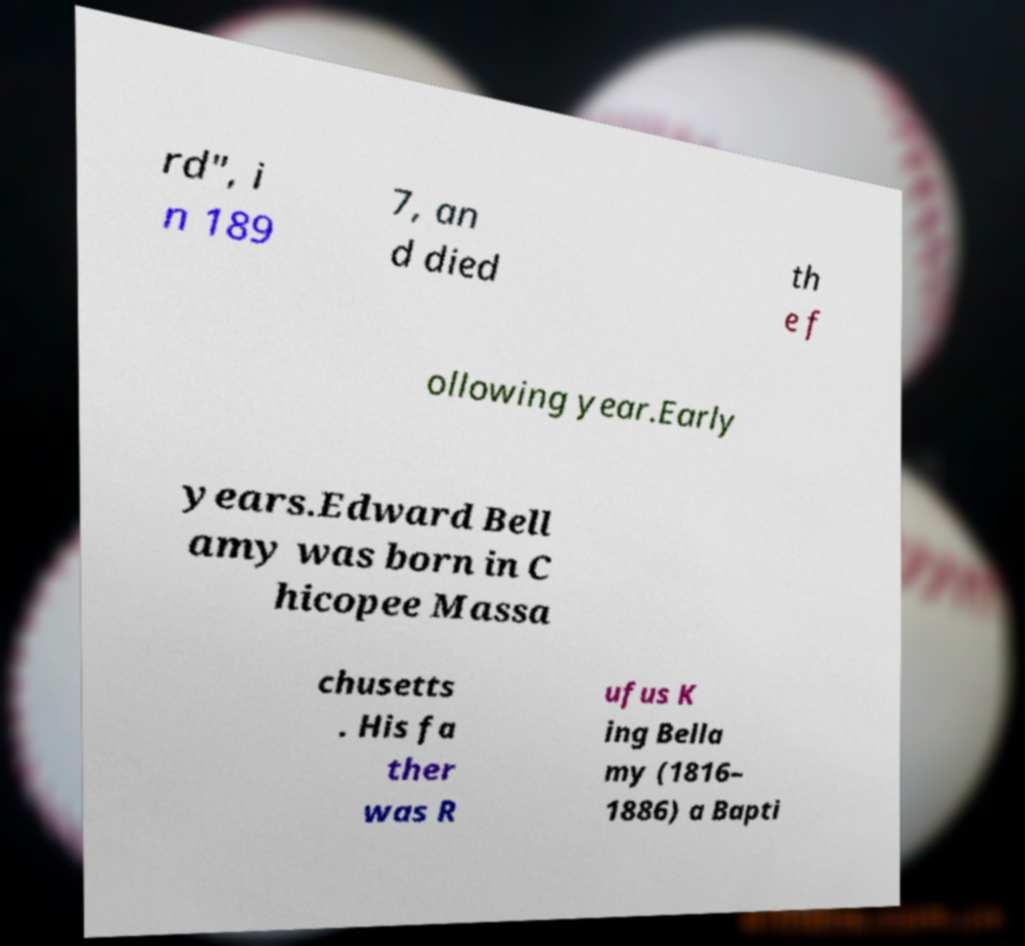Please read and relay the text visible in this image. What does it say? rd", i n 189 7, an d died th e f ollowing year.Early years.Edward Bell amy was born in C hicopee Massa chusetts . His fa ther was R ufus K ing Bella my (1816– 1886) a Bapti 